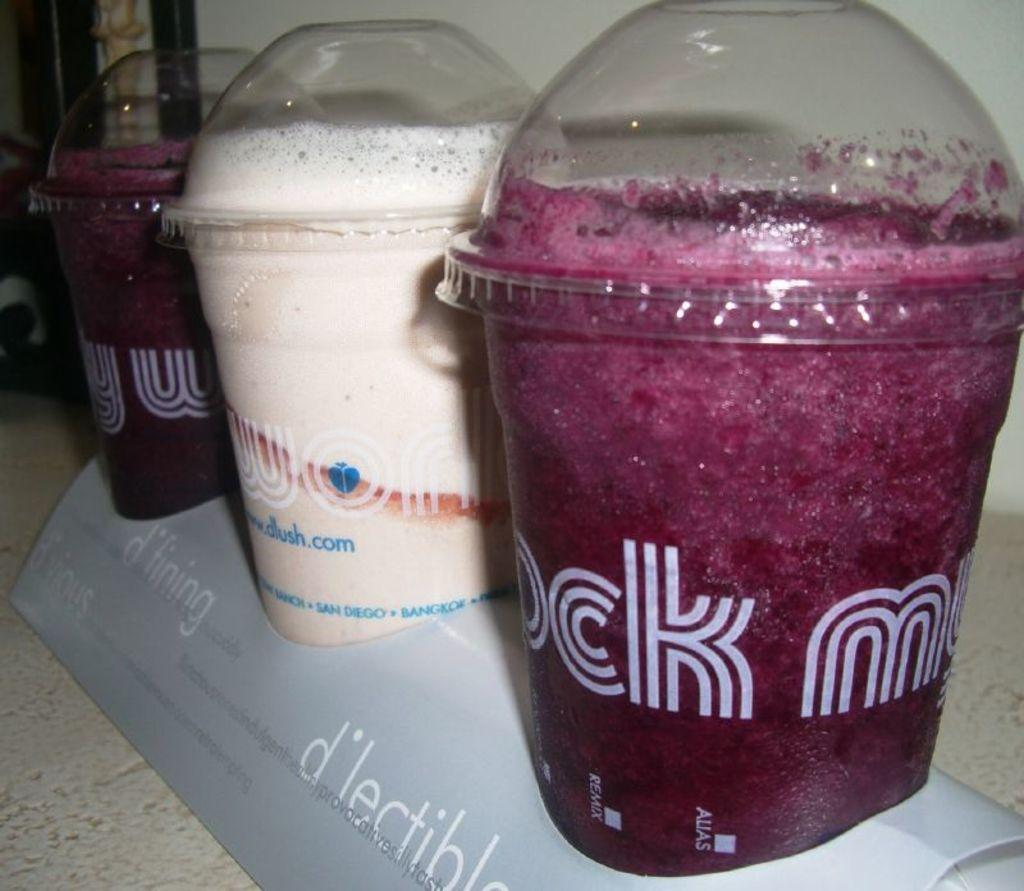<image>
Summarize the visual content of the image. Three iced drinks from dlush are in a cardboard container. 